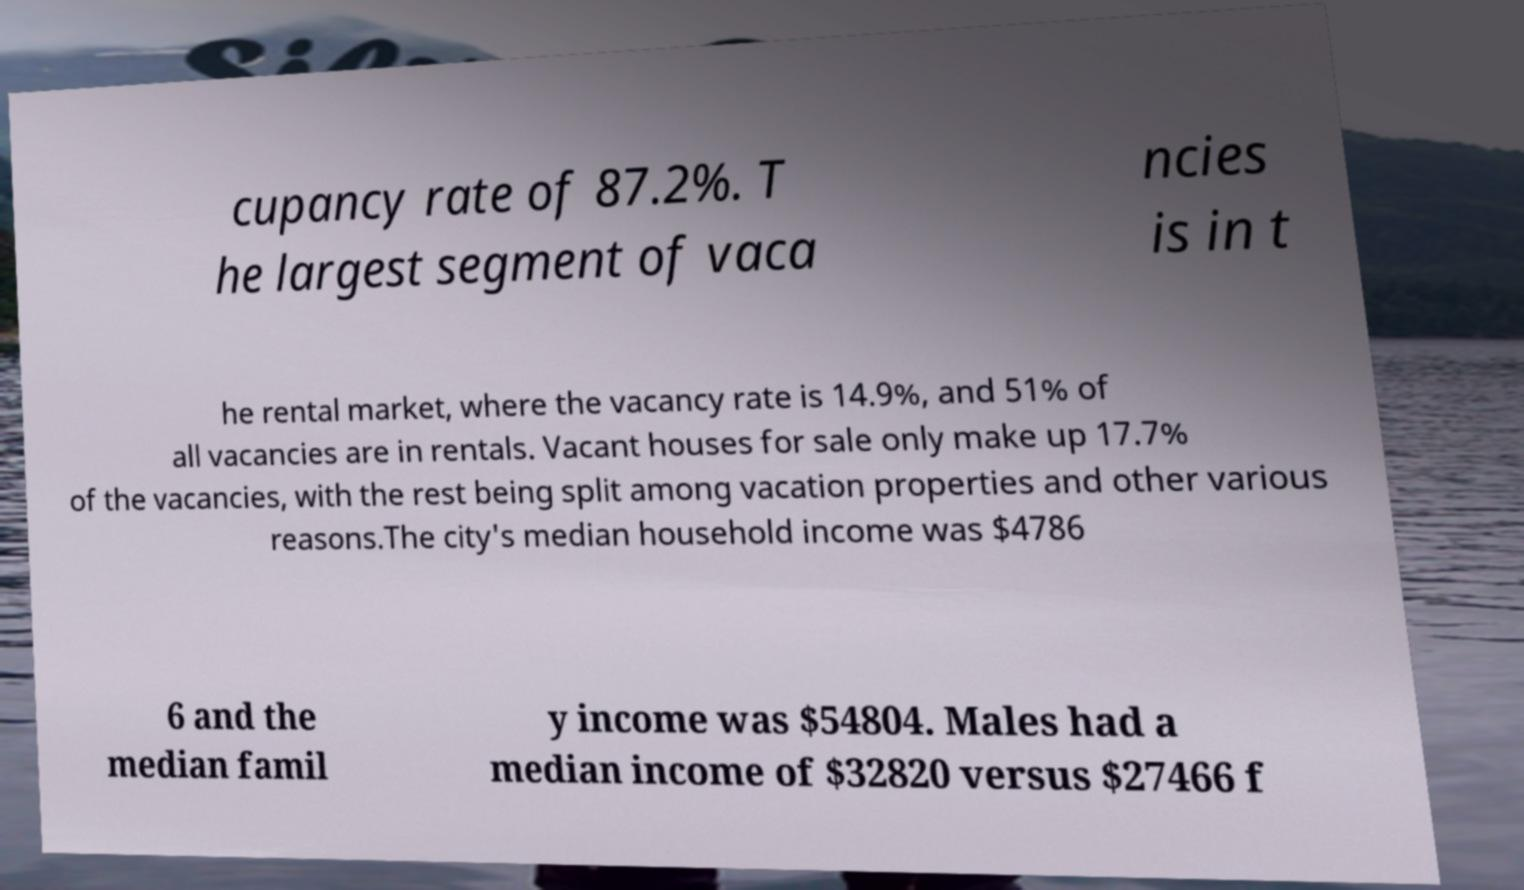Could you assist in decoding the text presented in this image and type it out clearly? cupancy rate of 87.2%. T he largest segment of vaca ncies is in t he rental market, where the vacancy rate is 14.9%, and 51% of all vacancies are in rentals. Vacant houses for sale only make up 17.7% of the vacancies, with the rest being split among vacation properties and other various reasons.The city's median household income was $4786 6 and the median famil y income was $54804. Males had a median income of $32820 versus $27466 f 